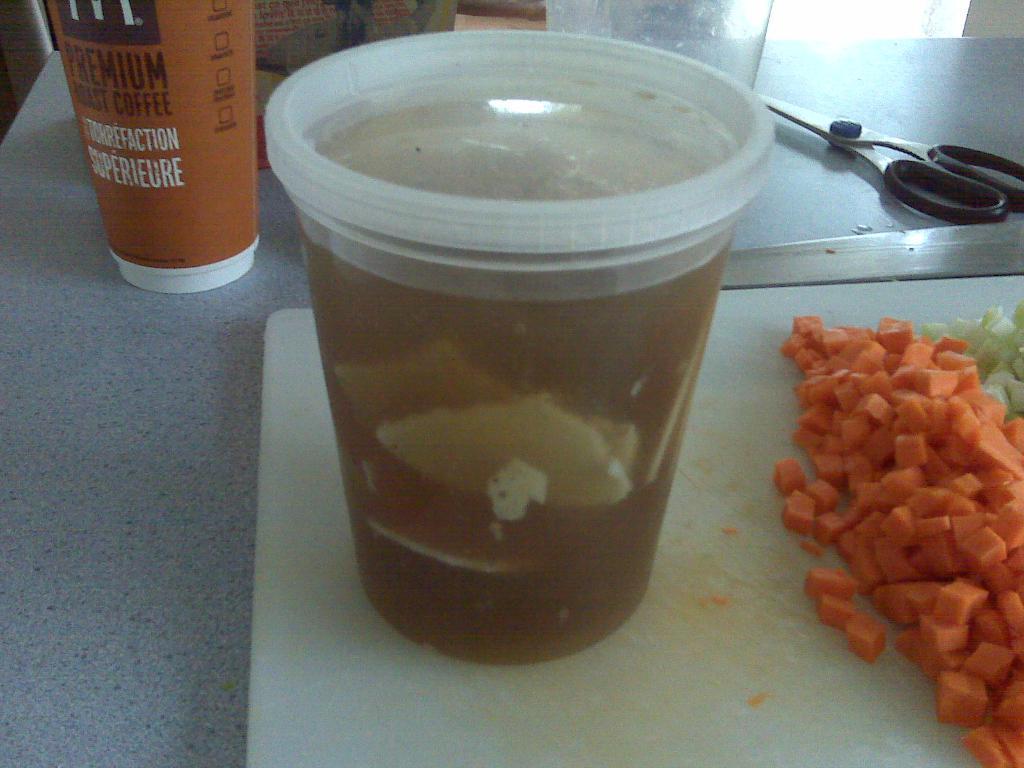Please provide a concise description of this image. In this picture we can see a chopper board, scissor, glasses, carrot pieces and these all are placed on a table. 